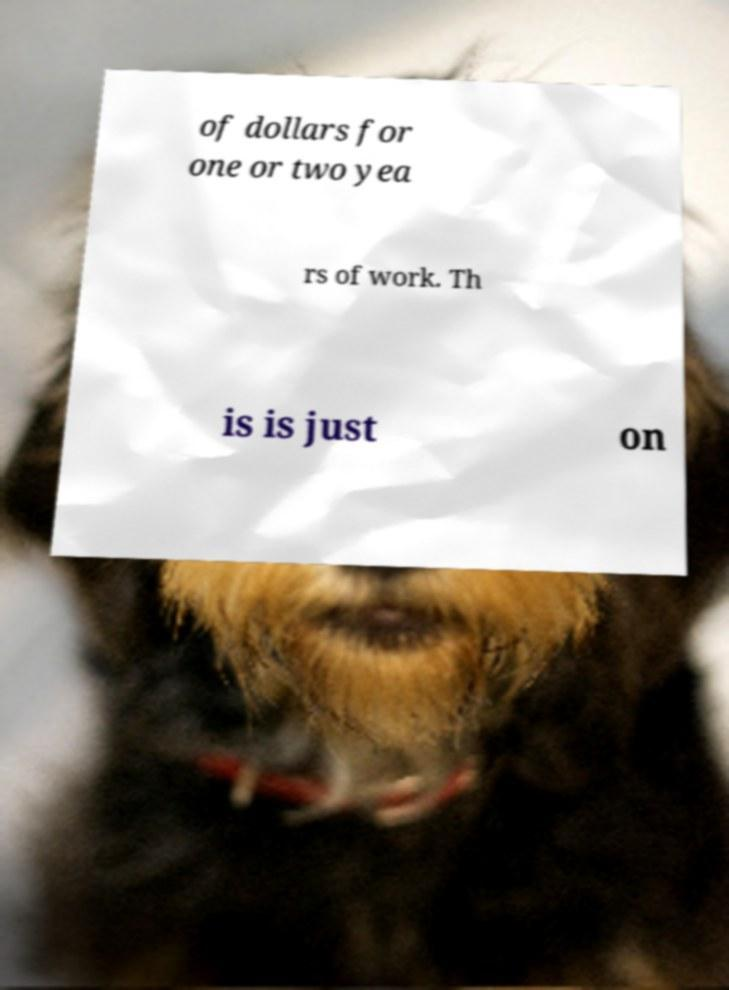Could you assist in decoding the text presented in this image and type it out clearly? of dollars for one or two yea rs of work. Th is is just on 